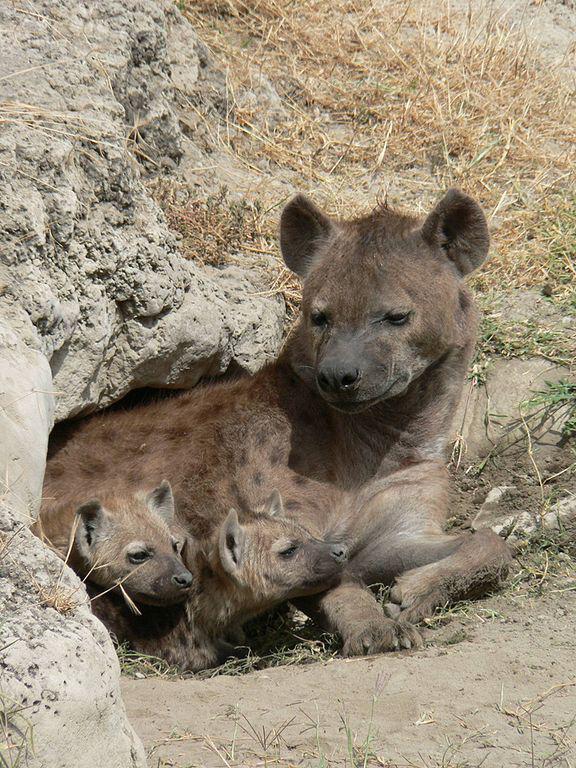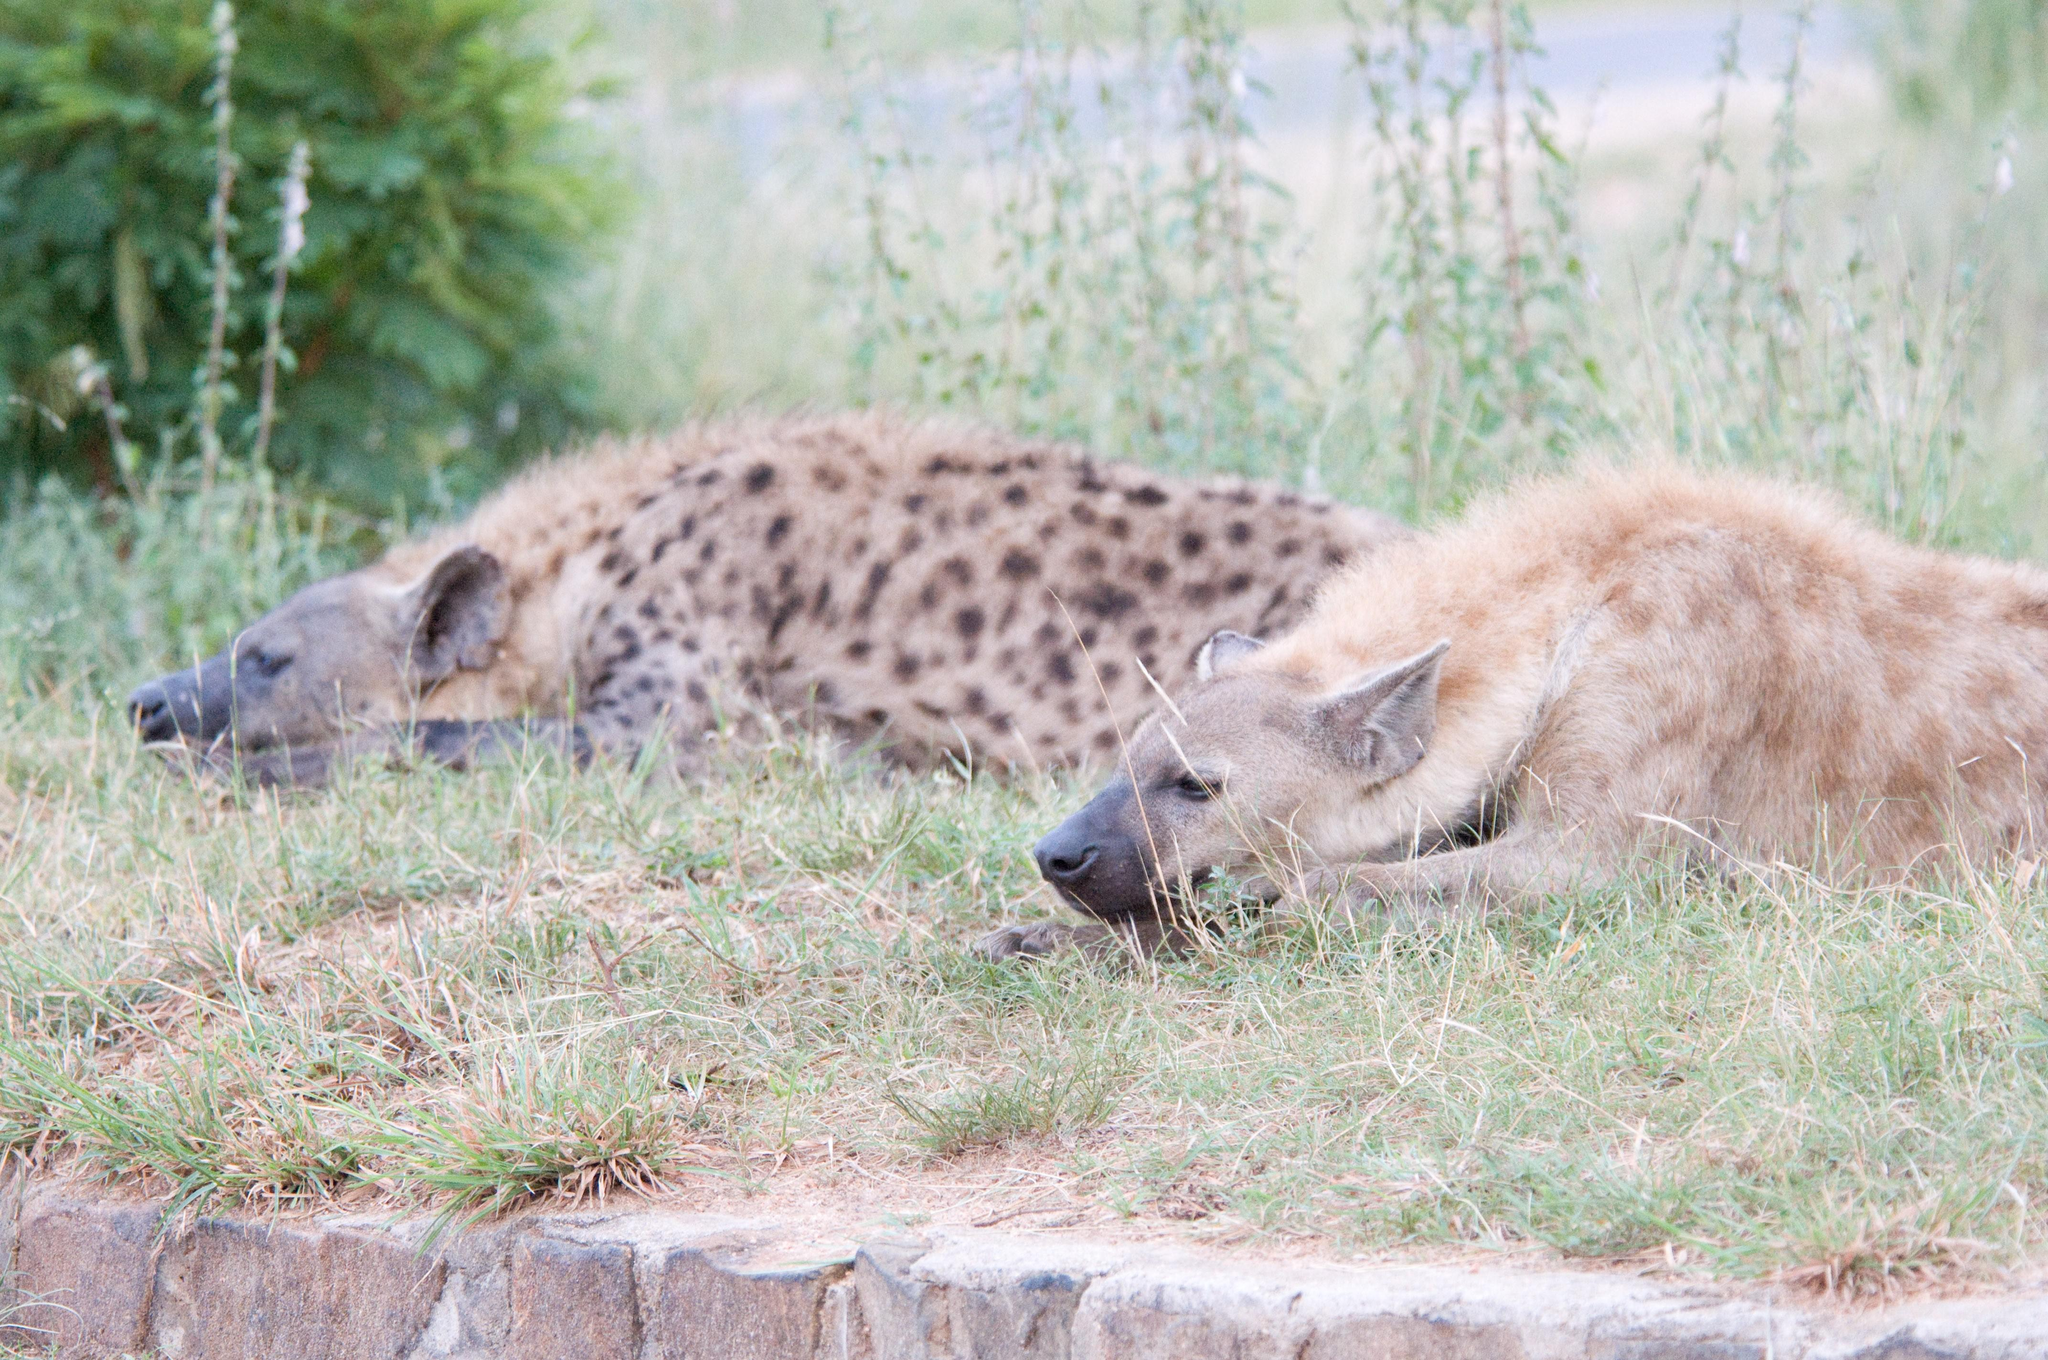The first image is the image on the left, the second image is the image on the right. For the images shown, is this caption "There are exactly four hyenas." true? Answer yes or no. No. The first image is the image on the left, the second image is the image on the right. Examine the images to the left and right. Is the description "The right image has two hyenas laying on the ground" accurate? Answer yes or no. Yes. 